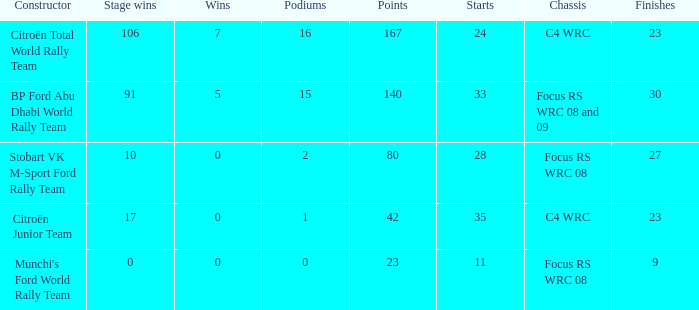What is the highest points when the chassis is focus rs wrc 08 and 09 and the stage wins is more than 91? None. 